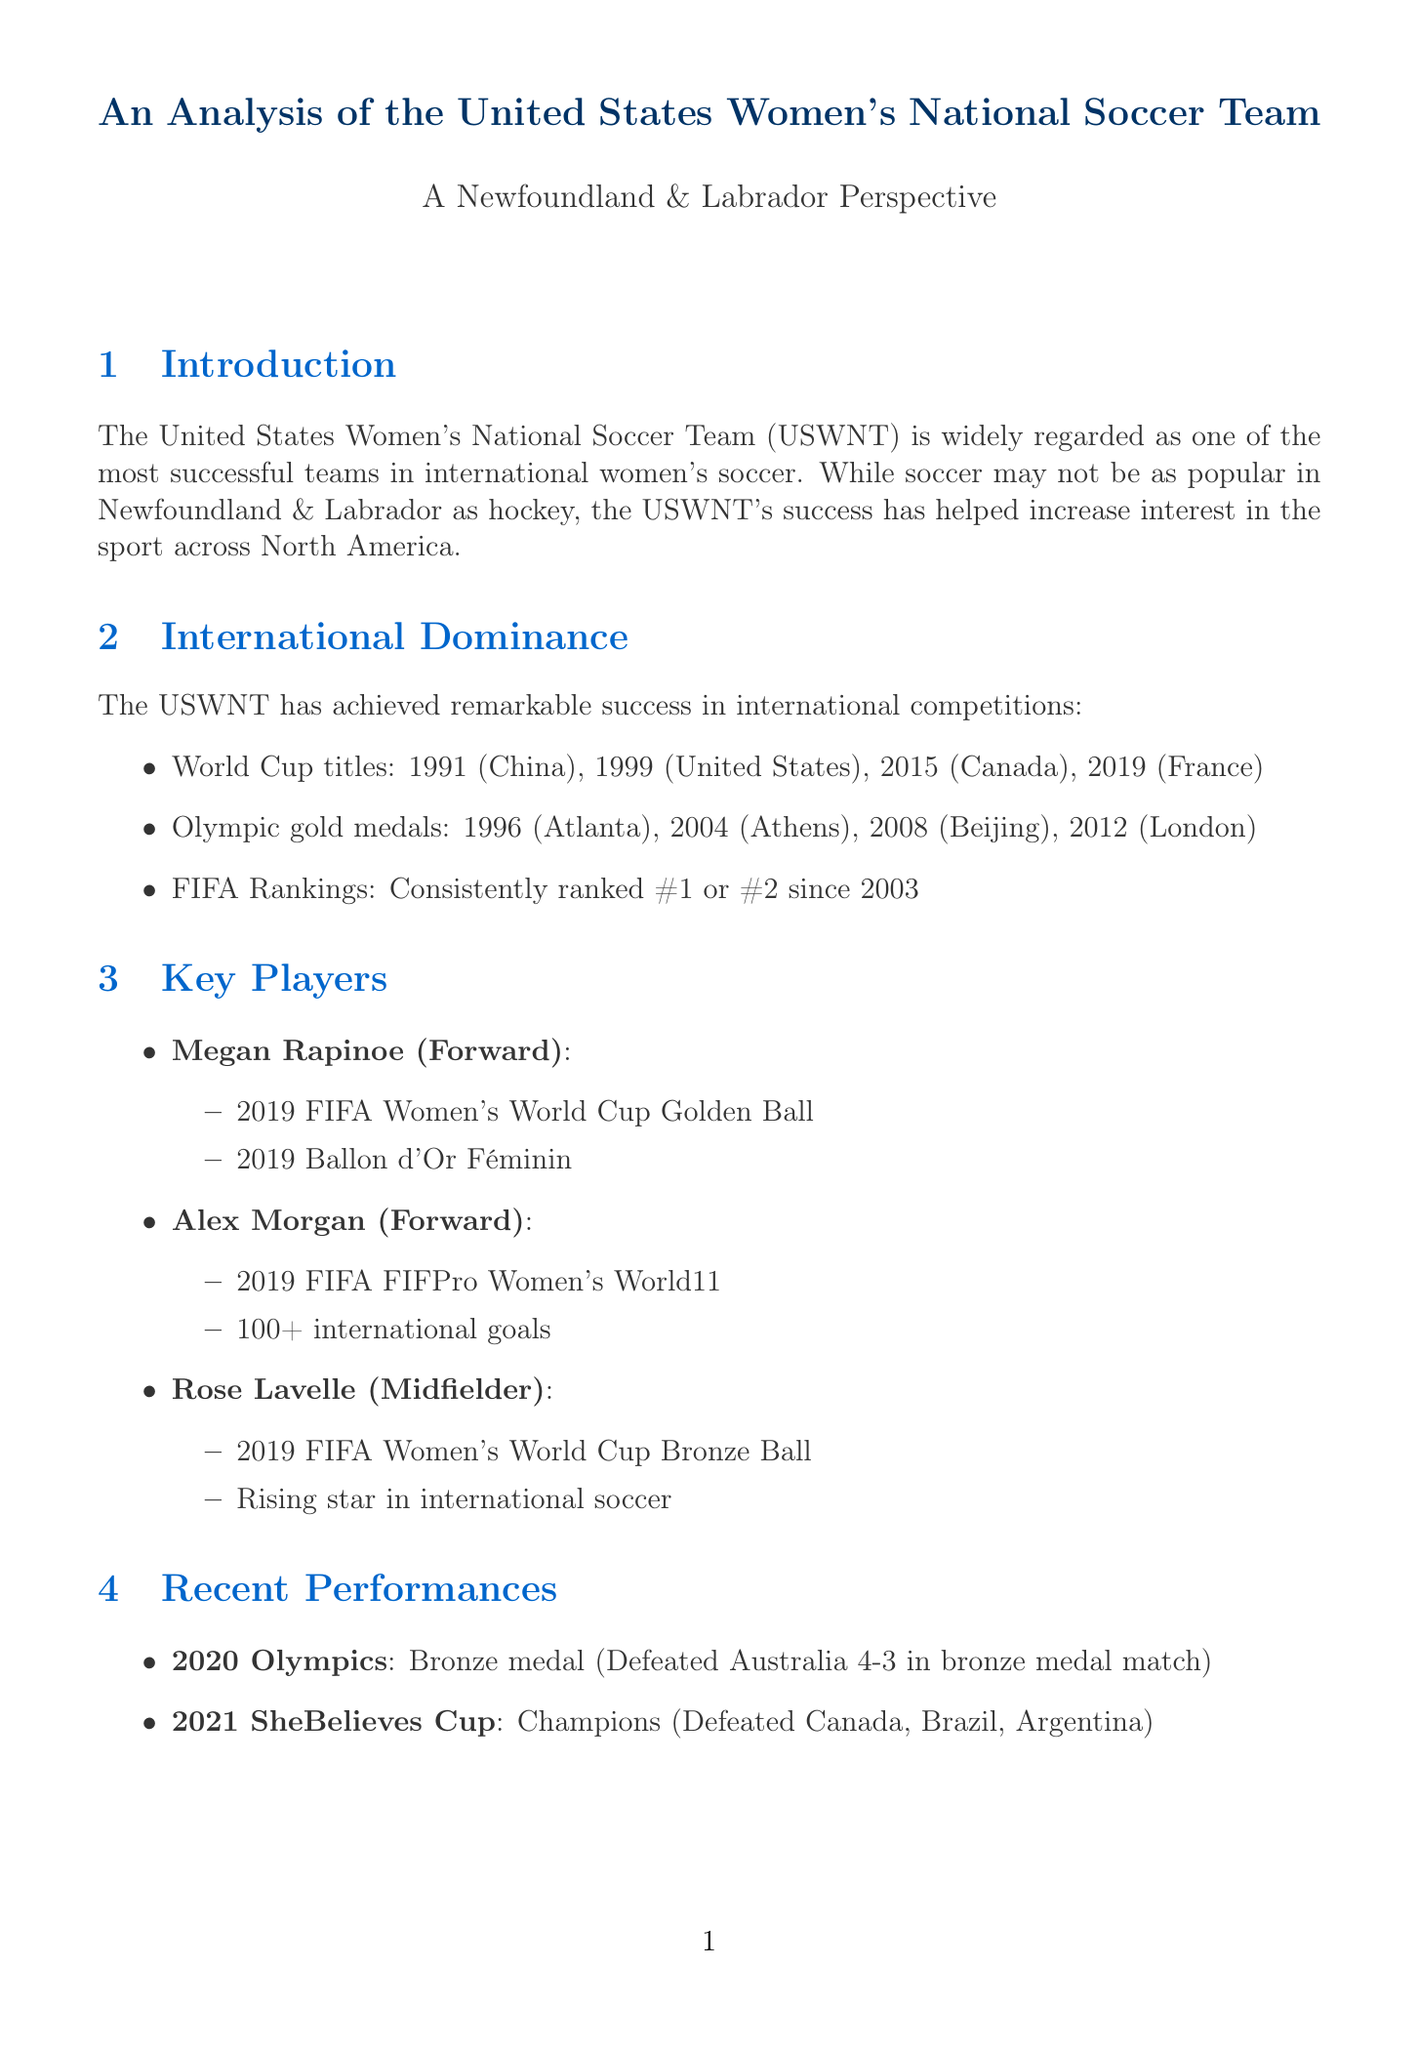what year did the USWNT win their first World Cup? The document states that the USWNT won their first World Cup in 1991.
Answer: 1991 how many Olympic gold medals has the USWNT won? The document lists four Olympic gold medals won by the USWNT.
Answer: 4 who is a key player known for winning the 2019 FIFA Women's World Cup Golden Ball? The document mentions Megan Rapinoe as the player who won the 2019 FIFA Women's World Cup Golden Ball.
Answer: Megan Rapinoe which notable match did the USWNT play against Canada in 2012? The document references the 2012 Olympic semifinal as a notable match.
Answer: 2012 Olympic semifinal how did the USWNT perform in the 2020 Olympics? The document states that the USWNT won a bronze medal in the 2020 Olympics.
Answer: Bronze medal who is considered one of the most promising young players in women's soccer? Catarina Macario is described in the document as one of the most promising young players.
Answer: Catarina Macario what were the results of the USWNT in the 2021 SheBelieves Cup? The document indicates that the USWNT became champions by defeating Canada, Brazil, and Argentina.
Answer: Champions what upcoming tournament is scheduled for 2023 for the USWNT? The document mentions the 2023 FIFA Women's World Cup in Australia and New Zealand.
Answer: 2023 FIFA Women's World Cup what is the main impact of the USWNT highlighted in the document? The document emphasizes that the USWNT's success has raised the profile of women's soccer worldwide.
Answer: Raised the profile of women's soccer worldwide 